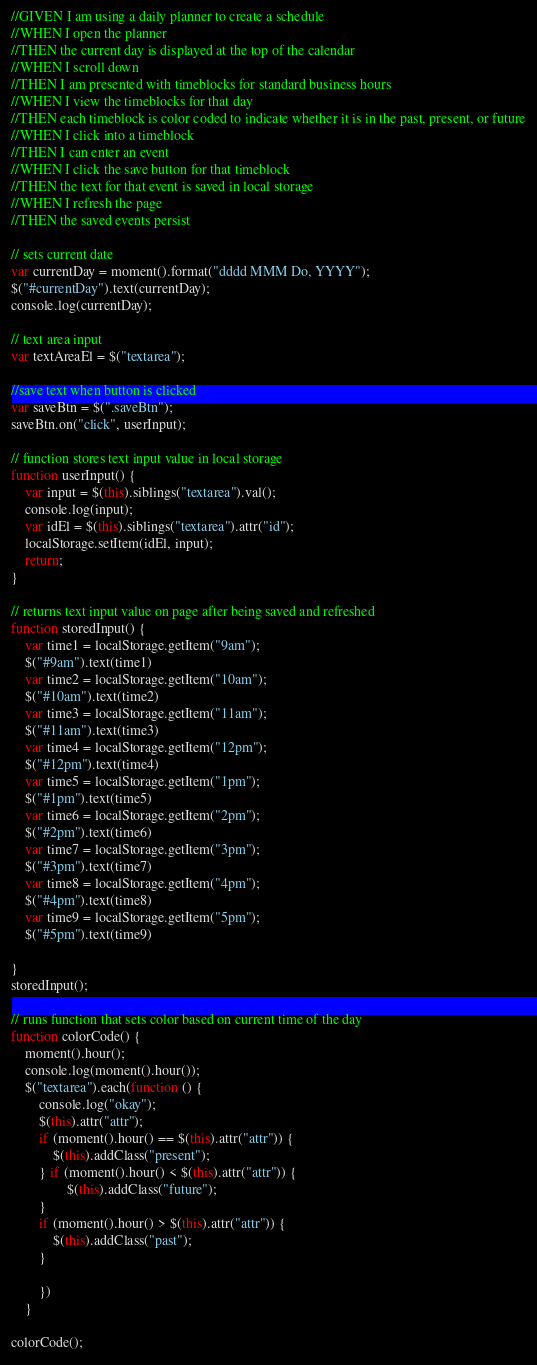Convert code to text. <code><loc_0><loc_0><loc_500><loc_500><_JavaScript_>//GIVEN I am using a daily planner to create a schedule
//WHEN I open the planner
//THEN the current day is displayed at the top of the calendar
//WHEN I scroll down
//THEN I am presented with timeblocks for standard business hours
//WHEN I view the timeblocks for that day
//THEN each timeblock is color coded to indicate whether it is in the past, present, or future
//WHEN I click into a timeblock
//THEN I can enter an event
//WHEN I click the save button for that timeblock
//THEN the text for that event is saved in local storage
//WHEN I refresh the page
//THEN the saved events persist

// sets current date 
var currentDay = moment().format("dddd MMM Do, YYYY");
$("#currentDay").text(currentDay);
console.log(currentDay);

// text area input
var textAreaEl = $("textarea");

//save text when button is clicked
var saveBtn = $(".saveBtn");
saveBtn.on("click", userInput);

// function stores text input value in local storage
function userInput() {
    var input = $(this).siblings("textarea").val();
    console.log(input);
    var idEl = $(this).siblings("textarea").attr("id");
    localStorage.setItem(idEl, input);
    return;
}

// returns text input value on page after being saved and refreshed 
function storedInput() {
    var time1 = localStorage.getItem("9am");
    $("#9am").text(time1)
    var time2 = localStorage.getItem("10am");
    $("#10am").text(time2)
    var time3 = localStorage.getItem("11am");
    $("#11am").text(time3)
    var time4 = localStorage.getItem("12pm");
    $("#12pm").text(time4)
    var time5 = localStorage.getItem("1pm");
    $("#1pm").text(time5)
    var time6 = localStorage.getItem("2pm");
    $("#2pm").text(time6)
    var time7 = localStorage.getItem("3pm");
    $("#3pm").text(time7)
    var time8 = localStorage.getItem("4pm");
    $("#4pm").text(time8)
    var time9 = localStorage.getItem("5pm");
    $("#5pm").text(time9)

}
storedInput();

// runs function that sets color based on current time of the day
function colorCode() {
    moment().hour();
    console.log(moment().hour());
    $("textarea").each(function () {
        console.log("okay");
        $(this).attr("attr");
        if (moment().hour() == $(this).attr("attr")) {
            $(this).addClass("present");
        } if (moment().hour() < $(this).attr("attr")) {
                $(this).addClass("future");
        }        
        if (moment().hour() > $(this).attr("attr")) {
            $(this).addClass("past");
        }

        })
    }      

colorCode();</code> 